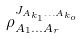Convert formula to latex. <formula><loc_0><loc_0><loc_500><loc_500>\rho _ { A _ { 1 } \dots A _ { r } } ^ { J _ { A _ { k _ { 1 } } \dots A _ { k _ { o } } } }</formula> 